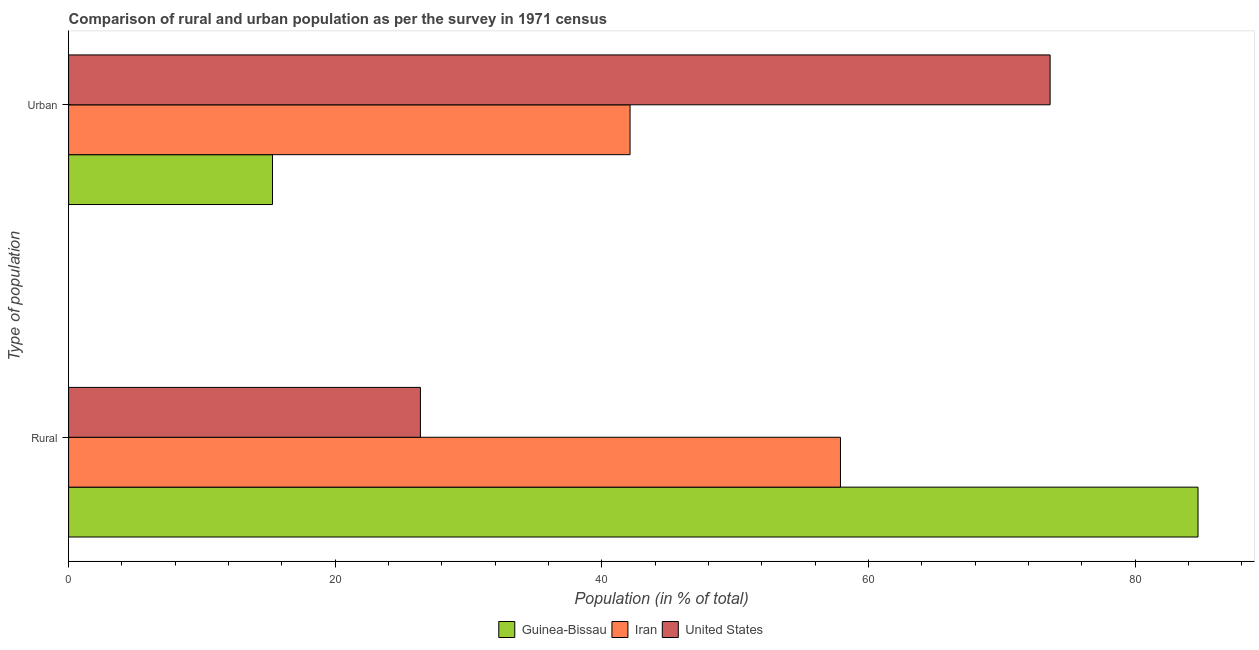How many different coloured bars are there?
Your response must be concise. 3. How many groups of bars are there?
Give a very brief answer. 2. Are the number of bars per tick equal to the number of legend labels?
Give a very brief answer. Yes. Are the number of bars on each tick of the Y-axis equal?
Ensure brevity in your answer.  Yes. How many bars are there on the 2nd tick from the top?
Ensure brevity in your answer.  3. How many bars are there on the 2nd tick from the bottom?
Keep it short and to the point. 3. What is the label of the 1st group of bars from the top?
Provide a short and direct response. Urban. What is the urban population in Guinea-Bissau?
Make the answer very short. 15.29. Across all countries, what is the maximum urban population?
Make the answer very short. 73.61. Across all countries, what is the minimum rural population?
Ensure brevity in your answer.  26.39. What is the total urban population in the graph?
Provide a succinct answer. 131.02. What is the difference between the rural population in United States and that in Iran?
Your answer should be compact. -31.5. What is the difference between the urban population in Iran and the rural population in Guinea-Bissau?
Give a very brief answer. -42.6. What is the average urban population per country?
Ensure brevity in your answer.  43.67. What is the difference between the urban population and rural population in Iran?
Provide a short and direct response. -15.78. In how many countries, is the rural population greater than 68 %?
Provide a succinct answer. 1. What is the ratio of the rural population in United States to that in Guinea-Bissau?
Offer a very short reply. 0.31. In how many countries, is the urban population greater than the average urban population taken over all countries?
Ensure brevity in your answer.  1. What does the 3rd bar from the top in Urban represents?
Your answer should be compact. Guinea-Bissau. What does the 1st bar from the bottom in Urban represents?
Your response must be concise. Guinea-Bissau. Are the values on the major ticks of X-axis written in scientific E-notation?
Your answer should be very brief. No. Does the graph contain any zero values?
Give a very brief answer. No. Where does the legend appear in the graph?
Offer a very short reply. Bottom center. How many legend labels are there?
Offer a very short reply. 3. How are the legend labels stacked?
Offer a very short reply. Horizontal. What is the title of the graph?
Your response must be concise. Comparison of rural and urban population as per the survey in 1971 census. What is the label or title of the X-axis?
Your answer should be compact. Population (in % of total). What is the label or title of the Y-axis?
Make the answer very short. Type of population. What is the Population (in % of total) of Guinea-Bissau in Rural?
Provide a succinct answer. 84.71. What is the Population (in % of total) in Iran in Rural?
Make the answer very short. 57.89. What is the Population (in % of total) of United States in Rural?
Your answer should be very brief. 26.39. What is the Population (in % of total) in Guinea-Bissau in Urban?
Ensure brevity in your answer.  15.29. What is the Population (in % of total) in Iran in Urban?
Make the answer very short. 42.11. What is the Population (in % of total) in United States in Urban?
Offer a terse response. 73.61. Across all Type of population, what is the maximum Population (in % of total) in Guinea-Bissau?
Your answer should be compact. 84.71. Across all Type of population, what is the maximum Population (in % of total) in Iran?
Ensure brevity in your answer.  57.89. Across all Type of population, what is the maximum Population (in % of total) of United States?
Make the answer very short. 73.61. Across all Type of population, what is the minimum Population (in % of total) in Guinea-Bissau?
Offer a very short reply. 15.29. Across all Type of population, what is the minimum Population (in % of total) of Iran?
Make the answer very short. 42.11. Across all Type of population, what is the minimum Population (in % of total) of United States?
Ensure brevity in your answer.  26.39. What is the total Population (in % of total) in United States in the graph?
Make the answer very short. 100. What is the difference between the Population (in % of total) of Guinea-Bissau in Rural and that in Urban?
Ensure brevity in your answer.  69.41. What is the difference between the Population (in % of total) of Iran in Rural and that in Urban?
Give a very brief answer. 15.78. What is the difference between the Population (in % of total) in United States in Rural and that in Urban?
Offer a very short reply. -47.23. What is the difference between the Population (in % of total) of Guinea-Bissau in Rural and the Population (in % of total) of Iran in Urban?
Ensure brevity in your answer.  42.6. What is the difference between the Population (in % of total) of Guinea-Bissau in Rural and the Population (in % of total) of United States in Urban?
Provide a short and direct response. 11.09. What is the difference between the Population (in % of total) of Iran in Rural and the Population (in % of total) of United States in Urban?
Give a very brief answer. -15.72. What is the average Population (in % of total) of Guinea-Bissau per Type of population?
Offer a very short reply. 50. What is the average Population (in % of total) of United States per Type of population?
Your answer should be compact. 50. What is the difference between the Population (in % of total) in Guinea-Bissau and Population (in % of total) in Iran in Rural?
Offer a very short reply. 26.82. What is the difference between the Population (in % of total) in Guinea-Bissau and Population (in % of total) in United States in Rural?
Offer a very short reply. 58.32. What is the difference between the Population (in % of total) of Iran and Population (in % of total) of United States in Rural?
Give a very brief answer. 31.5. What is the difference between the Population (in % of total) of Guinea-Bissau and Population (in % of total) of Iran in Urban?
Provide a succinct answer. -26.82. What is the difference between the Population (in % of total) in Guinea-Bissau and Population (in % of total) in United States in Urban?
Your response must be concise. -58.32. What is the difference between the Population (in % of total) of Iran and Population (in % of total) of United States in Urban?
Ensure brevity in your answer.  -31.5. What is the ratio of the Population (in % of total) in Guinea-Bissau in Rural to that in Urban?
Offer a terse response. 5.54. What is the ratio of the Population (in % of total) of Iran in Rural to that in Urban?
Make the answer very short. 1.37. What is the ratio of the Population (in % of total) in United States in Rural to that in Urban?
Give a very brief answer. 0.36. What is the difference between the highest and the second highest Population (in % of total) in Guinea-Bissau?
Ensure brevity in your answer.  69.41. What is the difference between the highest and the second highest Population (in % of total) in Iran?
Your response must be concise. 15.78. What is the difference between the highest and the second highest Population (in % of total) of United States?
Your response must be concise. 47.23. What is the difference between the highest and the lowest Population (in % of total) of Guinea-Bissau?
Your answer should be compact. 69.41. What is the difference between the highest and the lowest Population (in % of total) of Iran?
Ensure brevity in your answer.  15.78. What is the difference between the highest and the lowest Population (in % of total) of United States?
Ensure brevity in your answer.  47.23. 